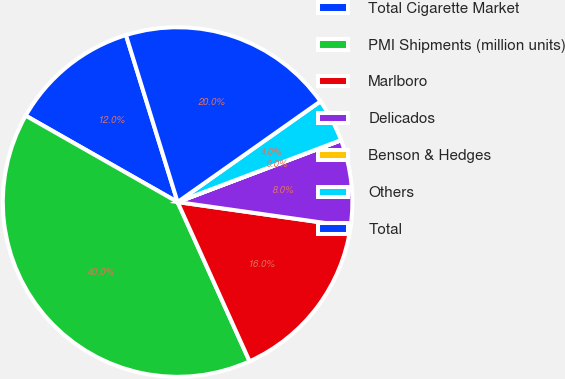Convert chart. <chart><loc_0><loc_0><loc_500><loc_500><pie_chart><fcel>Total Cigarette Market<fcel>PMI Shipments (million units)<fcel>Marlboro<fcel>Delicados<fcel>Benson & Hedges<fcel>Others<fcel>Total<nl><fcel>12.0%<fcel>39.99%<fcel>16.0%<fcel>8.0%<fcel>0.01%<fcel>4.01%<fcel>20.0%<nl></chart> 